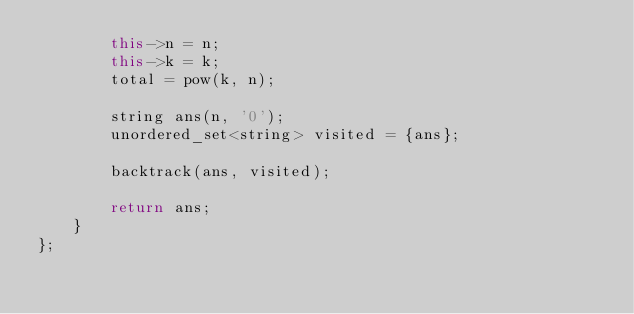<code> <loc_0><loc_0><loc_500><loc_500><_C++_>        this->n = n;
        this->k = k;
        total = pow(k, n);
        
        string ans(n, '0');
        unordered_set<string> visited = {ans};
        
        backtrack(ans, visited);
        
        return ans;
    }
};
</code> 